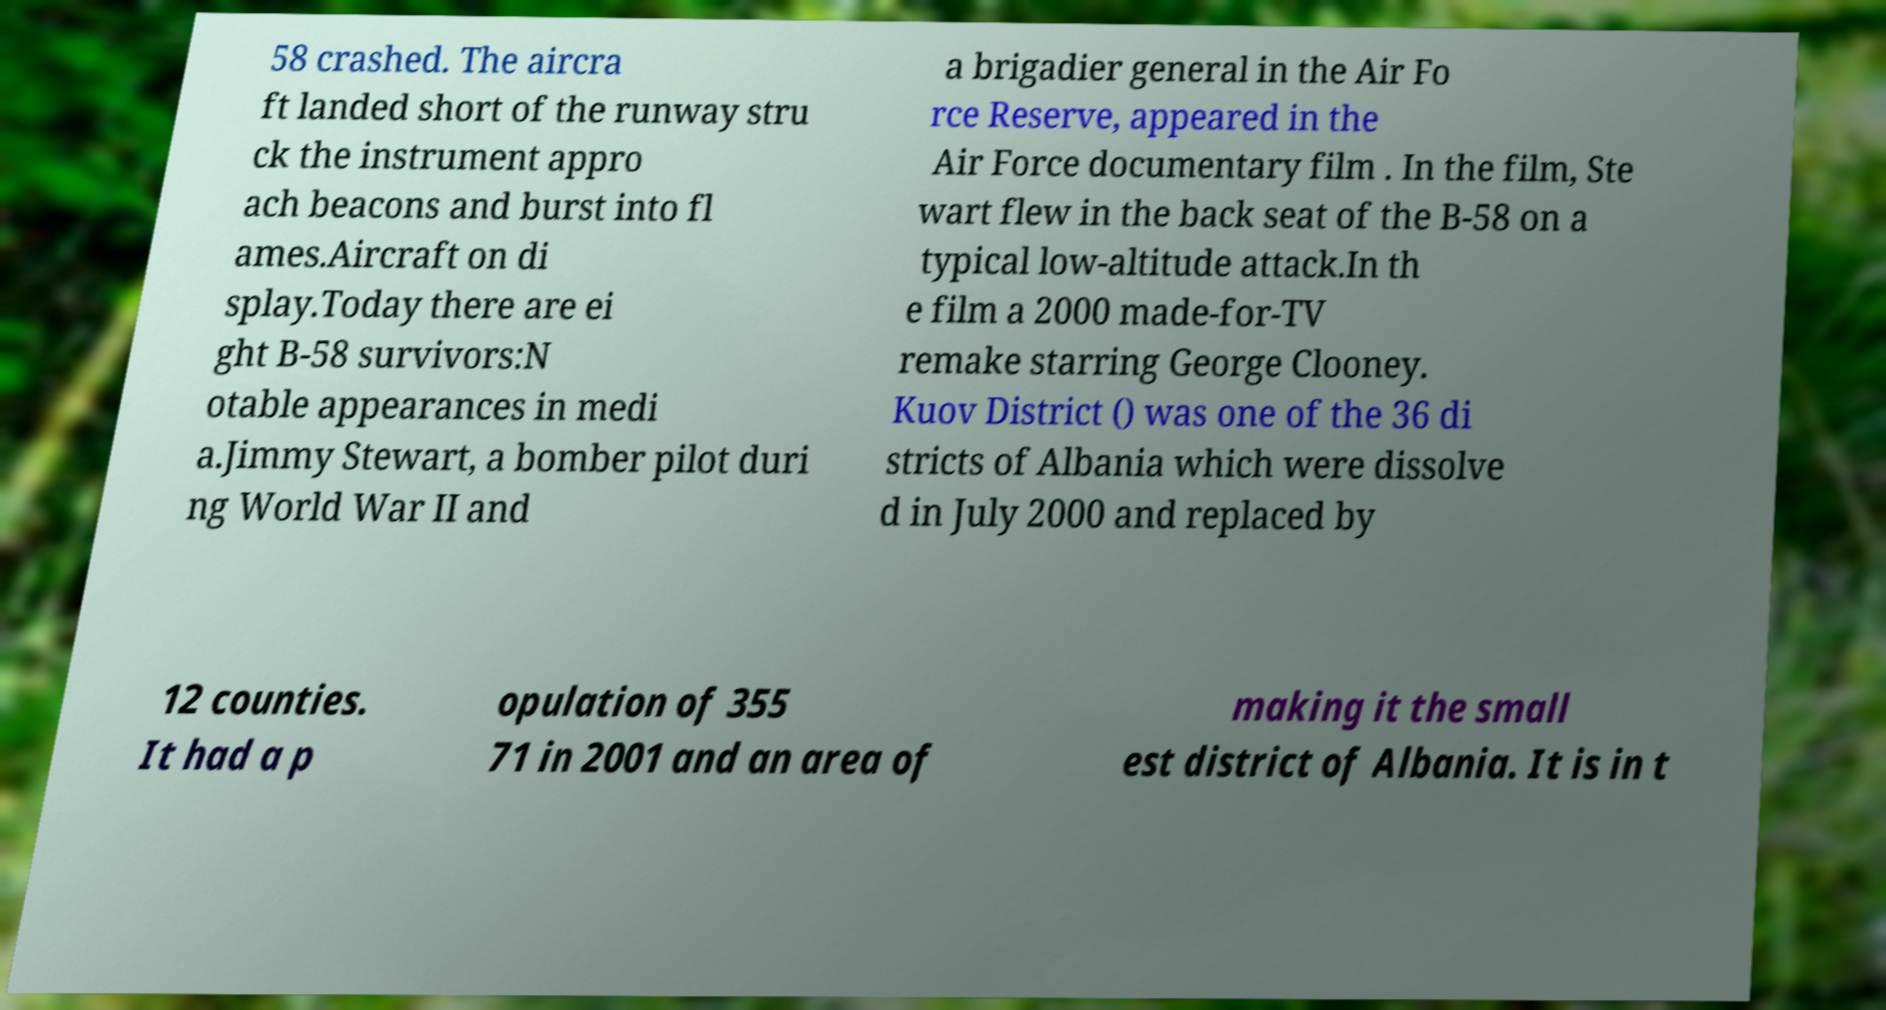Could you extract and type out the text from this image? 58 crashed. The aircra ft landed short of the runway stru ck the instrument appro ach beacons and burst into fl ames.Aircraft on di splay.Today there are ei ght B-58 survivors:N otable appearances in medi a.Jimmy Stewart, a bomber pilot duri ng World War II and a brigadier general in the Air Fo rce Reserve, appeared in the Air Force documentary film . In the film, Ste wart flew in the back seat of the B-58 on a typical low-altitude attack.In th e film a 2000 made-for-TV remake starring George Clooney. Kuov District () was one of the 36 di stricts of Albania which were dissolve d in July 2000 and replaced by 12 counties. It had a p opulation of 355 71 in 2001 and an area of making it the small est district of Albania. It is in t 